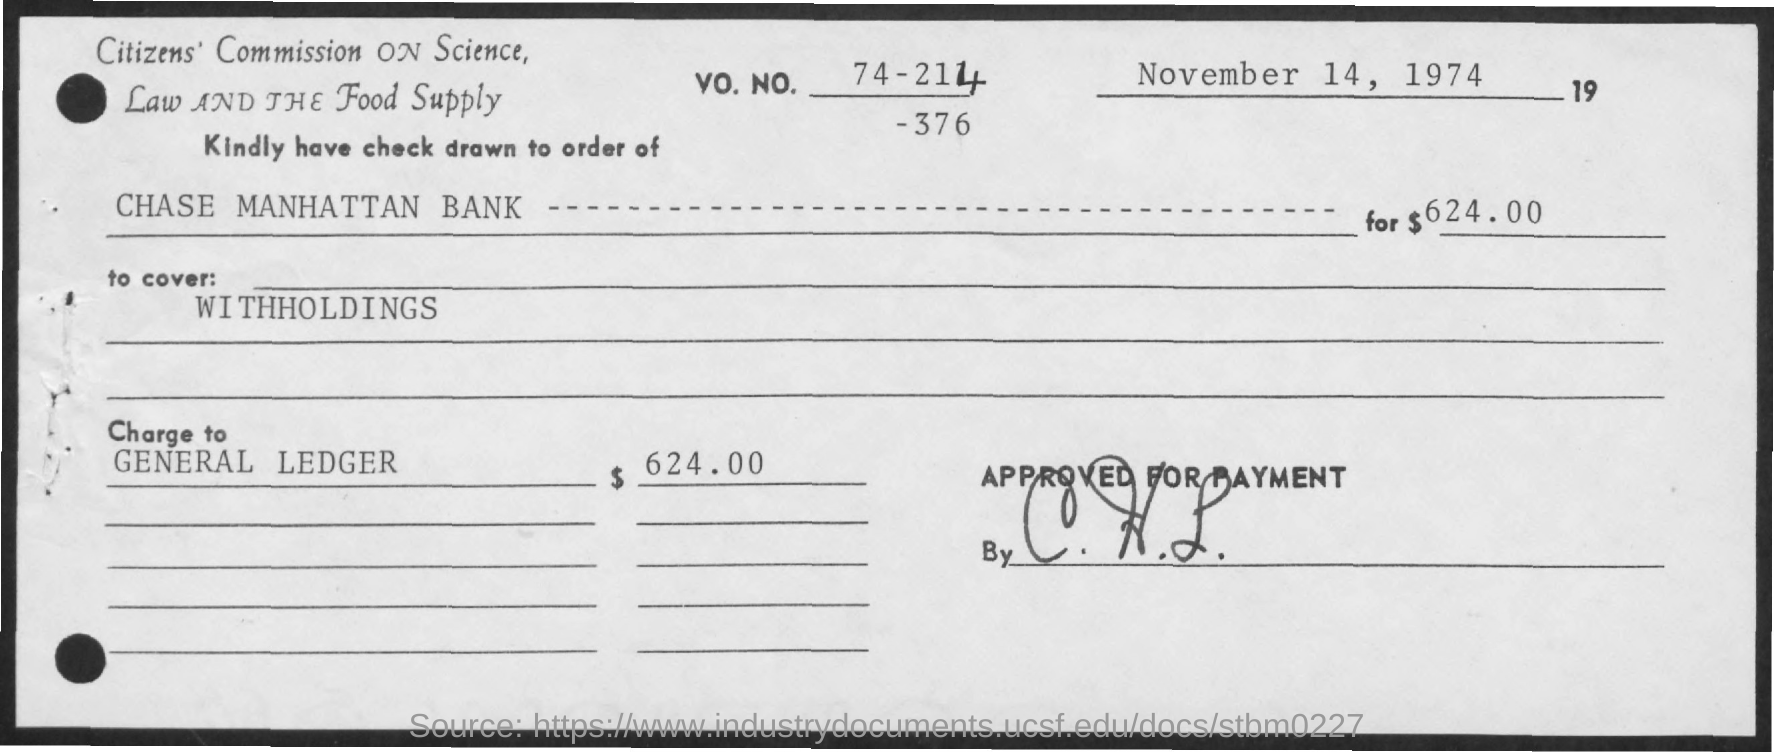List a handful of essential elements in this visual. The amount of 624.00 has been charged to the general ledger. The date mentioned is November 14, 1974. 